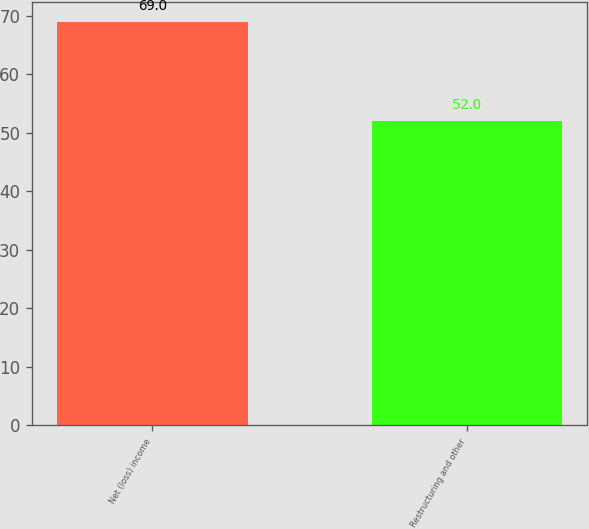<chart> <loc_0><loc_0><loc_500><loc_500><bar_chart><fcel>Net (loss) income<fcel>Restructuring and other<nl><fcel>69<fcel>52<nl></chart> 